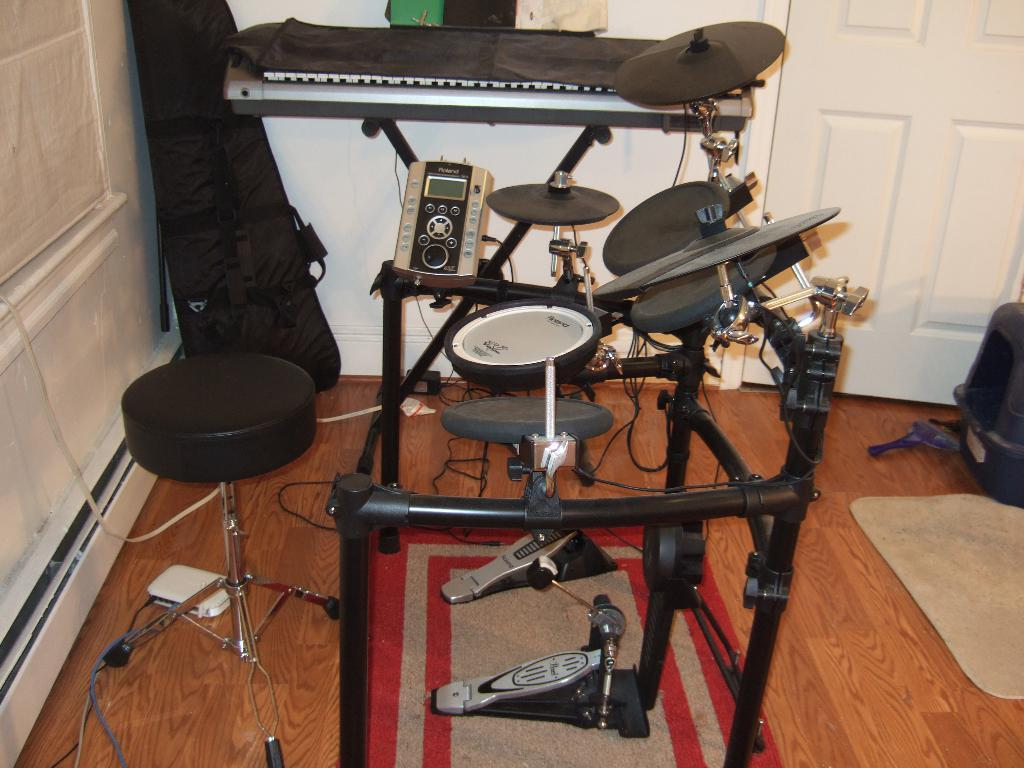What objects in the image are related to music? There are musical instruments in the image. What type of bag is present in the image? There is a guitar bag in the image. What piece of furniture is in the image? There is a stool in the image. What architectural features can be seen in the image? There is a door and a wall in the image. What is on the floor in the image? There is a mat on the floor in the image. What else can be seen in the image? There are wires visible in the image. Where is the shoe located in the image? There is no shoe present in the image. What type of stretch can be seen in the image? There is no stretch or stretching activity depicted in the image. 